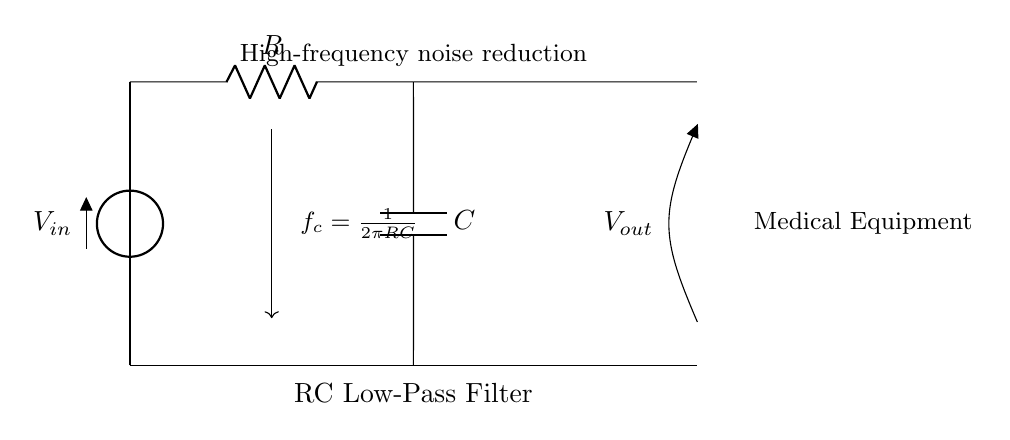What is the input voltage of the circuit? The input voltage is denoted as V_in, which represents the voltage supplied to the circuit.
Answer: V_in What type of filter is represented in this circuit? The circuit is identified as an RC low-pass filter, designed to allow low frequencies to pass while attenuating high frequencies.
Answer: RC low-pass filter What components are involved in this circuit? The circuit consists of a resistor (R) and a capacitor (C), which are the fundamental components of an RC filter.
Answer: Resistor and Capacitor What is the cutoff frequency formula for this filter? The cutoff frequency is indicated in the diagram as f_c = 1/(2πRC), meaning it depends on the values of R and C in the circuit.
Answer: f_c = 1/(2πRC) How does the output voltage relate to the input voltage in terms of frequency? At frequencies below the cutoff frequency, the output voltage (V_out) closely follows the input voltage (V_in), while it drops significantly at frequencies above the cutoff.
Answer: V_out follows V_in What does the arrow in the circuit signify next to V_out? The arrow pointing next to V_out indicates that this is an open circuit output voltage measurement point where the output can be observed.
Answer: Measurement point for output voltage 